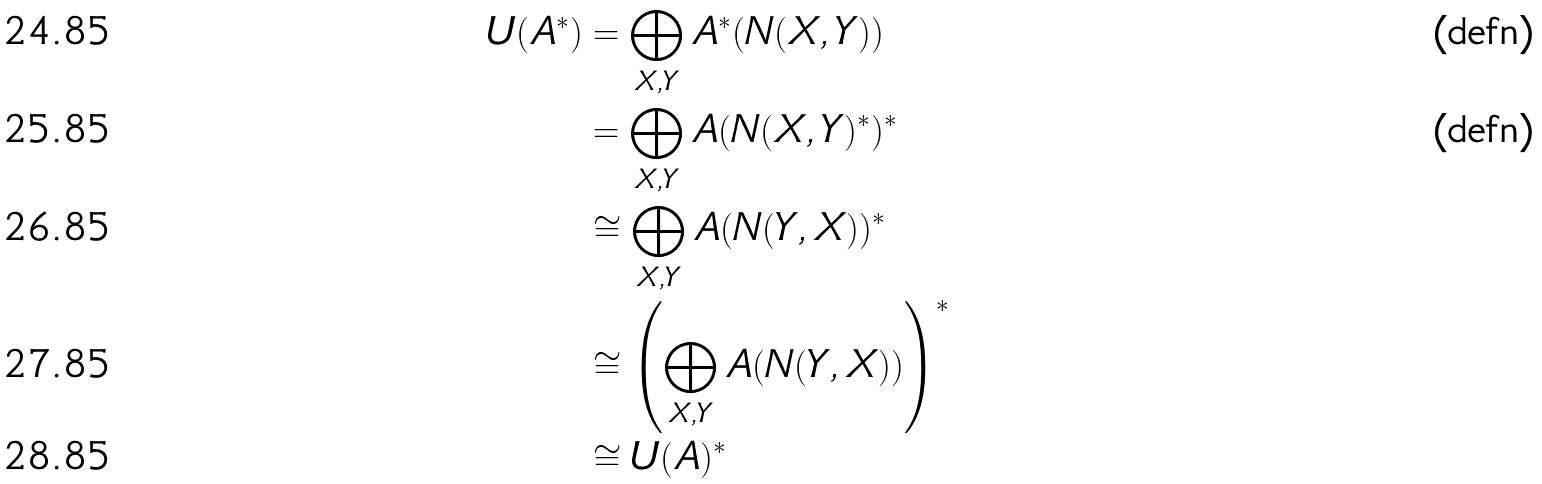<formula> <loc_0><loc_0><loc_500><loc_500>U ( A ^ { * } ) & = \bigoplus _ { X , Y } A ^ { * } ( N ( X , Y ) ) & \text {(defn)} \\ & = \bigoplus _ { X , Y } A ( N ( X , Y ) ^ { * } ) ^ { * } & \text {(defn)} \\ & \cong \bigoplus _ { X , Y } A ( N ( Y , X ) ) ^ { * } \\ & \cong \left ( \bigoplus _ { X , Y } A ( N ( Y , X ) ) \right ) ^ { * } \\ & \cong U ( A ) ^ { * }</formula> 